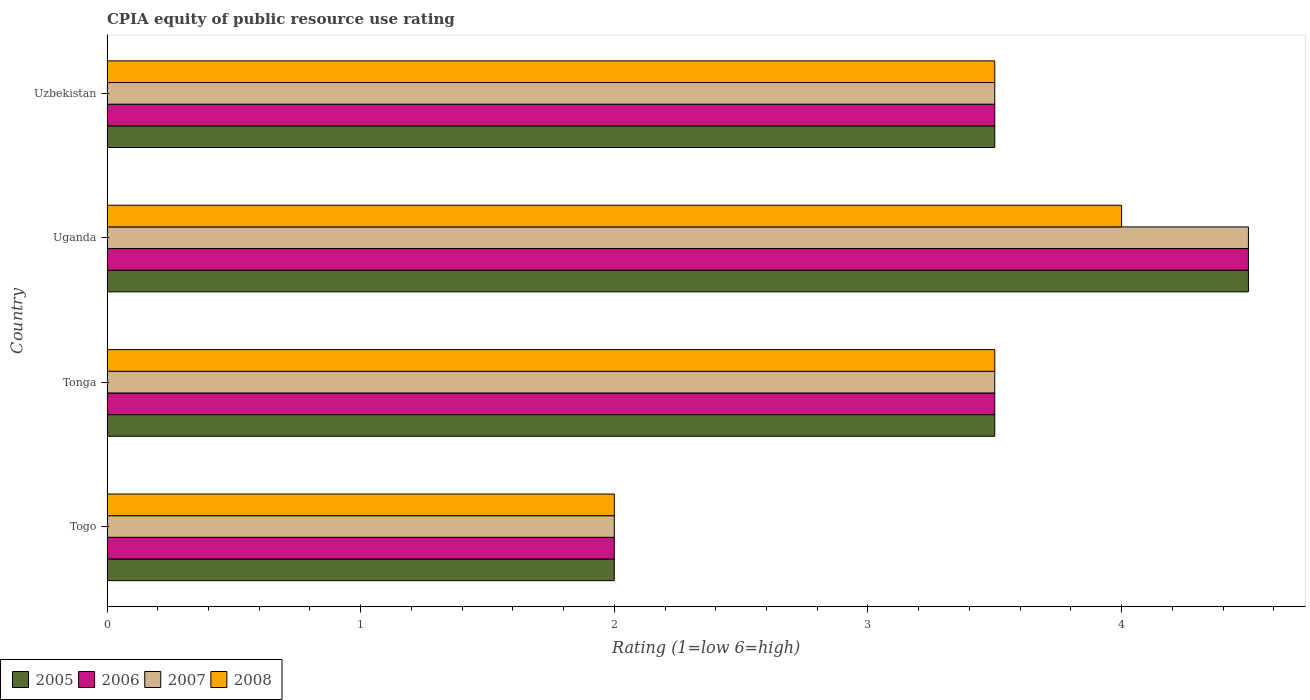Are the number of bars per tick equal to the number of legend labels?
Provide a short and direct response. Yes. How many bars are there on the 4th tick from the top?
Provide a short and direct response. 4. What is the label of the 3rd group of bars from the top?
Offer a terse response. Tonga. In how many cases, is the number of bars for a given country not equal to the number of legend labels?
Provide a succinct answer. 0. Across all countries, what is the minimum CPIA rating in 2007?
Provide a succinct answer. 2. In which country was the CPIA rating in 2006 maximum?
Keep it short and to the point. Uganda. In which country was the CPIA rating in 2008 minimum?
Your answer should be very brief. Togo. What is the average CPIA rating in 2008 per country?
Make the answer very short. 3.25. What is the ratio of the CPIA rating in 2006 in Uganda to that in Uzbekistan?
Offer a very short reply. 1.29. Is the difference between the CPIA rating in 2006 in Togo and Uzbekistan greater than the difference between the CPIA rating in 2005 in Togo and Uzbekistan?
Make the answer very short. No. What is the difference between the highest and the second highest CPIA rating in 2007?
Ensure brevity in your answer.  1. Is the sum of the CPIA rating in 2006 in Togo and Uzbekistan greater than the maximum CPIA rating in 2008 across all countries?
Make the answer very short. Yes. What does the 4th bar from the bottom in Tonga represents?
Provide a succinct answer. 2008. Are all the bars in the graph horizontal?
Offer a very short reply. Yes. How many countries are there in the graph?
Your response must be concise. 4. What is the difference between two consecutive major ticks on the X-axis?
Make the answer very short. 1. Does the graph contain any zero values?
Give a very brief answer. No. Where does the legend appear in the graph?
Make the answer very short. Bottom left. How many legend labels are there?
Your answer should be very brief. 4. What is the title of the graph?
Your response must be concise. CPIA equity of public resource use rating. Does "1976" appear as one of the legend labels in the graph?
Your answer should be compact. No. What is the label or title of the X-axis?
Your answer should be very brief. Rating (1=low 6=high). What is the Rating (1=low 6=high) in 2006 in Togo?
Keep it short and to the point. 2. What is the Rating (1=low 6=high) in 2008 in Togo?
Ensure brevity in your answer.  2. What is the Rating (1=low 6=high) of 2005 in Tonga?
Your answer should be compact. 3.5. What is the Rating (1=low 6=high) in 2006 in Tonga?
Provide a short and direct response. 3.5. What is the Rating (1=low 6=high) of 2008 in Tonga?
Give a very brief answer. 3.5. What is the Rating (1=low 6=high) in 2005 in Uganda?
Make the answer very short. 4.5. What is the Rating (1=low 6=high) in 2007 in Uganda?
Your answer should be compact. 4.5. What is the Rating (1=low 6=high) in 2008 in Uganda?
Provide a short and direct response. 4. What is the Rating (1=low 6=high) in 2007 in Uzbekistan?
Provide a succinct answer. 3.5. Across all countries, what is the maximum Rating (1=low 6=high) in 2005?
Keep it short and to the point. 4.5. Across all countries, what is the maximum Rating (1=low 6=high) of 2006?
Offer a very short reply. 4.5. Across all countries, what is the maximum Rating (1=low 6=high) of 2007?
Provide a short and direct response. 4.5. Across all countries, what is the maximum Rating (1=low 6=high) of 2008?
Your answer should be very brief. 4. Across all countries, what is the minimum Rating (1=low 6=high) of 2006?
Make the answer very short. 2. What is the total Rating (1=low 6=high) in 2005 in the graph?
Give a very brief answer. 13.5. What is the total Rating (1=low 6=high) of 2006 in the graph?
Your answer should be very brief. 13.5. What is the total Rating (1=low 6=high) of 2008 in the graph?
Make the answer very short. 13. What is the difference between the Rating (1=low 6=high) of 2006 in Togo and that in Tonga?
Keep it short and to the point. -1.5. What is the difference between the Rating (1=low 6=high) in 2007 in Togo and that in Tonga?
Provide a short and direct response. -1.5. What is the difference between the Rating (1=low 6=high) of 2006 in Togo and that in Uganda?
Offer a terse response. -2.5. What is the difference between the Rating (1=low 6=high) of 2005 in Togo and that in Uzbekistan?
Provide a succinct answer. -1.5. What is the difference between the Rating (1=low 6=high) of 2007 in Togo and that in Uzbekistan?
Provide a short and direct response. -1.5. What is the difference between the Rating (1=low 6=high) in 2006 in Tonga and that in Uganda?
Offer a terse response. -1. What is the difference between the Rating (1=low 6=high) in 2007 in Tonga and that in Uganda?
Give a very brief answer. -1. What is the difference between the Rating (1=low 6=high) in 2008 in Tonga and that in Uganda?
Your response must be concise. -0.5. What is the difference between the Rating (1=low 6=high) of 2005 in Tonga and that in Uzbekistan?
Give a very brief answer. 0. What is the difference between the Rating (1=low 6=high) of 2008 in Tonga and that in Uzbekistan?
Make the answer very short. 0. What is the difference between the Rating (1=low 6=high) of 2005 in Uganda and that in Uzbekistan?
Provide a succinct answer. 1. What is the difference between the Rating (1=low 6=high) in 2008 in Uganda and that in Uzbekistan?
Ensure brevity in your answer.  0.5. What is the difference between the Rating (1=low 6=high) of 2006 in Togo and the Rating (1=low 6=high) of 2008 in Tonga?
Give a very brief answer. -1.5. What is the difference between the Rating (1=low 6=high) of 2007 in Togo and the Rating (1=low 6=high) of 2008 in Tonga?
Your response must be concise. -1.5. What is the difference between the Rating (1=low 6=high) of 2005 in Togo and the Rating (1=low 6=high) of 2007 in Uganda?
Your answer should be compact. -2.5. What is the difference between the Rating (1=low 6=high) of 2005 in Togo and the Rating (1=low 6=high) of 2008 in Uganda?
Offer a very short reply. -2. What is the difference between the Rating (1=low 6=high) of 2006 in Togo and the Rating (1=low 6=high) of 2007 in Uganda?
Provide a succinct answer. -2.5. What is the difference between the Rating (1=low 6=high) of 2007 in Togo and the Rating (1=low 6=high) of 2008 in Uganda?
Your response must be concise. -2. What is the difference between the Rating (1=low 6=high) in 2005 in Togo and the Rating (1=low 6=high) in 2006 in Uzbekistan?
Your response must be concise. -1.5. What is the difference between the Rating (1=low 6=high) of 2005 in Togo and the Rating (1=low 6=high) of 2008 in Uzbekistan?
Your answer should be very brief. -1.5. What is the difference between the Rating (1=low 6=high) in 2006 in Togo and the Rating (1=low 6=high) in 2007 in Uzbekistan?
Your answer should be compact. -1.5. What is the difference between the Rating (1=low 6=high) of 2006 in Togo and the Rating (1=low 6=high) of 2008 in Uzbekistan?
Ensure brevity in your answer.  -1.5. What is the difference between the Rating (1=low 6=high) of 2005 in Tonga and the Rating (1=low 6=high) of 2007 in Uzbekistan?
Give a very brief answer. 0. What is the difference between the Rating (1=low 6=high) of 2005 in Tonga and the Rating (1=low 6=high) of 2008 in Uzbekistan?
Give a very brief answer. 0. What is the difference between the Rating (1=low 6=high) in 2007 in Tonga and the Rating (1=low 6=high) in 2008 in Uzbekistan?
Your answer should be compact. 0. What is the difference between the Rating (1=low 6=high) in 2005 in Uganda and the Rating (1=low 6=high) in 2007 in Uzbekistan?
Your answer should be compact. 1. What is the difference between the Rating (1=low 6=high) of 2006 in Uganda and the Rating (1=low 6=high) of 2007 in Uzbekistan?
Offer a very short reply. 1. What is the difference between the Rating (1=low 6=high) of 2006 in Uganda and the Rating (1=low 6=high) of 2008 in Uzbekistan?
Your answer should be compact. 1. What is the difference between the Rating (1=low 6=high) of 2007 in Uganda and the Rating (1=low 6=high) of 2008 in Uzbekistan?
Offer a very short reply. 1. What is the average Rating (1=low 6=high) of 2005 per country?
Your answer should be very brief. 3.38. What is the average Rating (1=low 6=high) of 2006 per country?
Your answer should be compact. 3.38. What is the average Rating (1=low 6=high) of 2007 per country?
Keep it short and to the point. 3.38. What is the difference between the Rating (1=low 6=high) in 2005 and Rating (1=low 6=high) in 2006 in Togo?
Give a very brief answer. 0. What is the difference between the Rating (1=low 6=high) in 2005 and Rating (1=low 6=high) in 2007 in Togo?
Your response must be concise. 0. What is the difference between the Rating (1=low 6=high) of 2005 and Rating (1=low 6=high) of 2008 in Togo?
Keep it short and to the point. 0. What is the difference between the Rating (1=low 6=high) of 2006 and Rating (1=low 6=high) of 2007 in Tonga?
Make the answer very short. 0. What is the difference between the Rating (1=low 6=high) of 2007 and Rating (1=low 6=high) of 2008 in Tonga?
Keep it short and to the point. 0. What is the difference between the Rating (1=low 6=high) of 2005 and Rating (1=low 6=high) of 2006 in Uganda?
Offer a terse response. 0. What is the difference between the Rating (1=low 6=high) of 2005 and Rating (1=low 6=high) of 2007 in Uganda?
Ensure brevity in your answer.  0. What is the difference between the Rating (1=low 6=high) in 2006 and Rating (1=low 6=high) in 2007 in Uganda?
Your answer should be compact. 0. What is the difference between the Rating (1=low 6=high) in 2006 and Rating (1=low 6=high) in 2008 in Uganda?
Keep it short and to the point. 0.5. What is the difference between the Rating (1=low 6=high) in 2005 and Rating (1=low 6=high) in 2006 in Uzbekistan?
Provide a succinct answer. 0. What is the difference between the Rating (1=low 6=high) of 2005 and Rating (1=low 6=high) of 2008 in Uzbekistan?
Your response must be concise. 0. What is the difference between the Rating (1=low 6=high) in 2007 and Rating (1=low 6=high) in 2008 in Uzbekistan?
Your answer should be compact. 0. What is the ratio of the Rating (1=low 6=high) in 2005 in Togo to that in Tonga?
Offer a very short reply. 0.57. What is the ratio of the Rating (1=low 6=high) of 2007 in Togo to that in Tonga?
Offer a terse response. 0.57. What is the ratio of the Rating (1=low 6=high) of 2005 in Togo to that in Uganda?
Make the answer very short. 0.44. What is the ratio of the Rating (1=low 6=high) of 2006 in Togo to that in Uganda?
Provide a short and direct response. 0.44. What is the ratio of the Rating (1=low 6=high) in 2007 in Togo to that in Uganda?
Ensure brevity in your answer.  0.44. What is the ratio of the Rating (1=low 6=high) of 2008 in Tonga to that in Uganda?
Provide a succinct answer. 0.88. What is the ratio of the Rating (1=low 6=high) in 2007 in Tonga to that in Uzbekistan?
Give a very brief answer. 1. What is the ratio of the Rating (1=low 6=high) of 2008 in Tonga to that in Uzbekistan?
Make the answer very short. 1. What is the ratio of the Rating (1=low 6=high) of 2005 in Uganda to that in Uzbekistan?
Offer a very short reply. 1.29. What is the ratio of the Rating (1=low 6=high) in 2006 in Uganda to that in Uzbekistan?
Your answer should be very brief. 1.29. What is the ratio of the Rating (1=low 6=high) in 2007 in Uganda to that in Uzbekistan?
Ensure brevity in your answer.  1.29. What is the difference between the highest and the second highest Rating (1=low 6=high) in 2006?
Your answer should be very brief. 1. What is the difference between the highest and the lowest Rating (1=low 6=high) in 2006?
Make the answer very short. 2.5. 